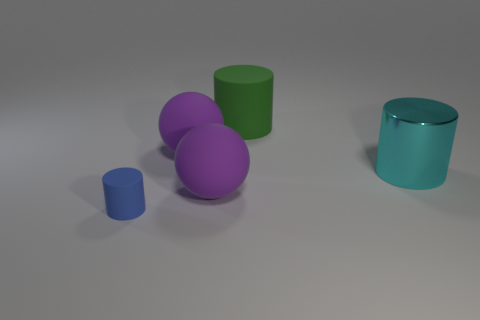Are there any other things that have the same material as the big cyan cylinder?
Keep it short and to the point. No. Is there anything else that is the same size as the blue thing?
Your answer should be compact. No. Is there a large red block?
Make the answer very short. No. Is the shape of the shiny thing the same as the small blue object left of the cyan object?
Your answer should be very brief. Yes. What is the material of the large cyan thing in front of the purple matte thing behind the cyan shiny cylinder?
Offer a terse response. Metal. The big rubber cylinder is what color?
Give a very brief answer. Green. Does the sphere behind the big cyan thing have the same color as the rubber sphere in front of the big cyan thing?
Offer a very short reply. Yes. There is a blue thing that is the same shape as the big green thing; what is its size?
Keep it short and to the point. Small. What number of things are either green cylinders that are behind the big cyan object or brown shiny balls?
Keep it short and to the point. 1. There is a large cylinder that is made of the same material as the small blue thing; what is its color?
Your answer should be compact. Green. 